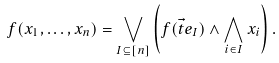Convert formula to latex. <formula><loc_0><loc_0><loc_500><loc_500>f ( x _ { 1 } , \dots , x _ { n } ) = \bigvee _ { I \subseteq [ n ] } \left ( f ( \vec { t } { e } _ { I } ) \wedge \bigwedge _ { i \in I } x _ { i } \right ) .</formula> 